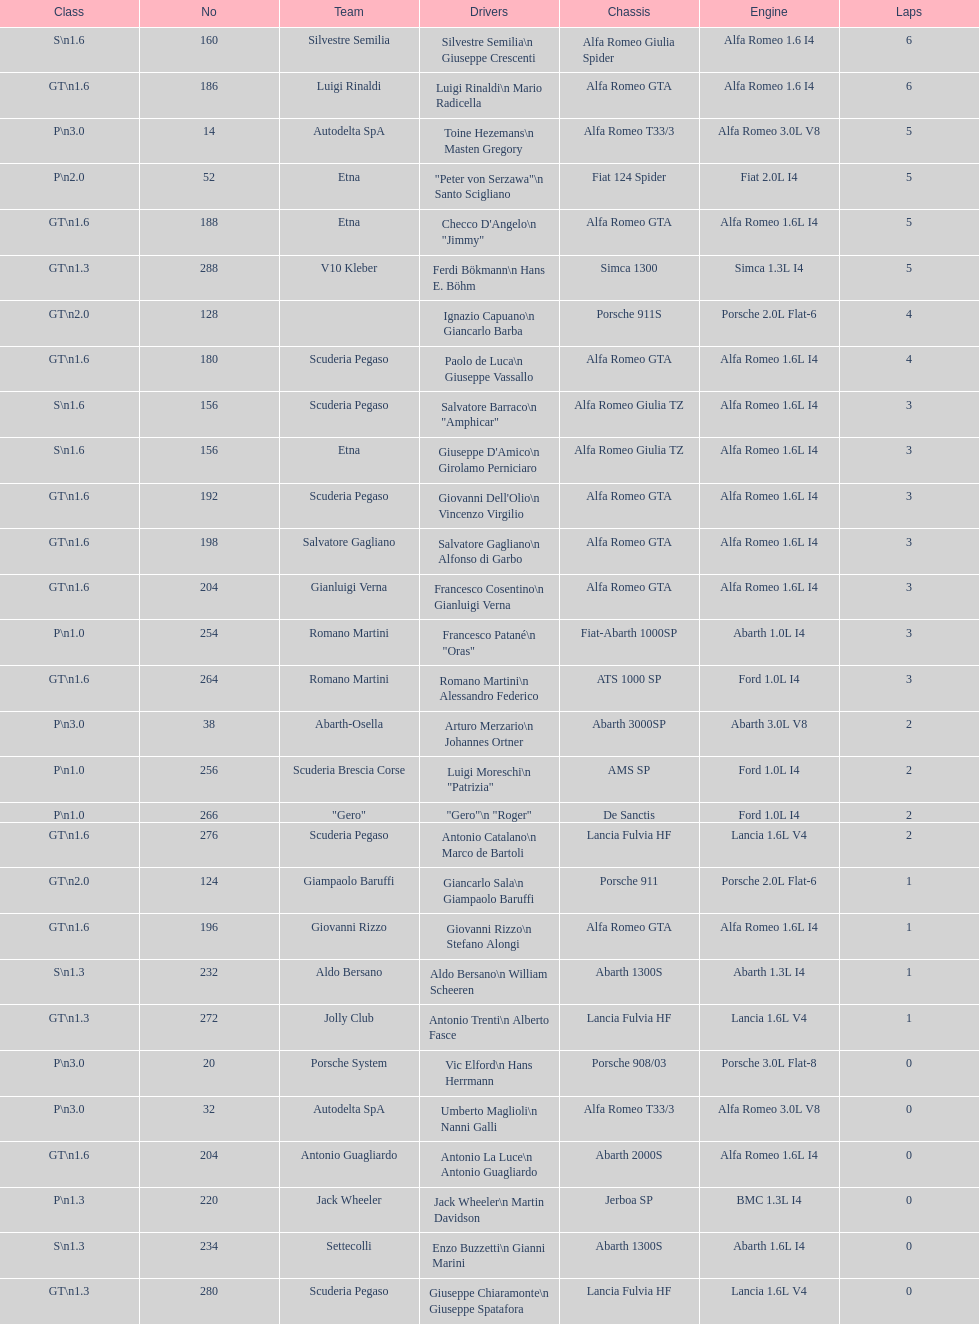What is the lap count for the v10 kleber? 5. 